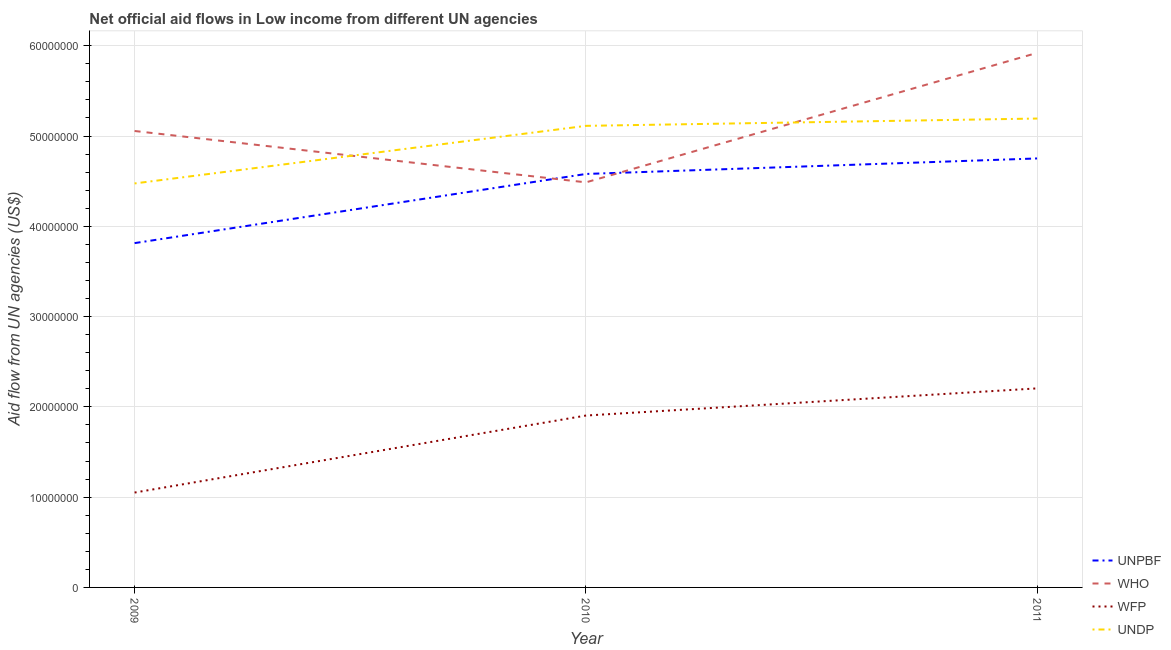How many different coloured lines are there?
Provide a succinct answer. 4. Is the number of lines equal to the number of legend labels?
Make the answer very short. Yes. What is the amount of aid given by who in 2011?
Make the answer very short. 5.92e+07. Across all years, what is the maximum amount of aid given by who?
Your answer should be compact. 5.92e+07. Across all years, what is the minimum amount of aid given by who?
Your answer should be compact. 4.49e+07. What is the total amount of aid given by undp in the graph?
Offer a very short reply. 1.48e+08. What is the difference between the amount of aid given by who in 2009 and that in 2010?
Offer a very short reply. 5.69e+06. What is the difference between the amount of aid given by unpbf in 2009 and the amount of aid given by who in 2010?
Your response must be concise. -6.73e+06. What is the average amount of aid given by who per year?
Provide a short and direct response. 5.16e+07. In the year 2009, what is the difference between the amount of aid given by wfp and amount of aid given by undp?
Provide a succinct answer. -3.42e+07. What is the ratio of the amount of aid given by unpbf in 2009 to that in 2011?
Offer a very short reply. 0.8. What is the difference between the highest and the second highest amount of aid given by who?
Your answer should be compact. 8.66e+06. What is the difference between the highest and the lowest amount of aid given by undp?
Your response must be concise. 7.19e+06. In how many years, is the amount of aid given by unpbf greater than the average amount of aid given by unpbf taken over all years?
Provide a short and direct response. 2. Is the sum of the amount of aid given by wfp in 2010 and 2011 greater than the maximum amount of aid given by who across all years?
Offer a terse response. No. Is it the case that in every year, the sum of the amount of aid given by unpbf and amount of aid given by undp is greater than the sum of amount of aid given by who and amount of aid given by wfp?
Give a very brief answer. No. Does the amount of aid given by undp monotonically increase over the years?
Offer a terse response. Yes. Does the graph contain grids?
Offer a very short reply. Yes. Where does the legend appear in the graph?
Your answer should be very brief. Bottom right. How many legend labels are there?
Your answer should be compact. 4. How are the legend labels stacked?
Give a very brief answer. Vertical. What is the title of the graph?
Give a very brief answer. Net official aid flows in Low income from different UN agencies. Does "Industry" appear as one of the legend labels in the graph?
Your answer should be compact. No. What is the label or title of the Y-axis?
Make the answer very short. Aid flow from UN agencies (US$). What is the Aid flow from UN agencies (US$) of UNPBF in 2009?
Keep it short and to the point. 3.81e+07. What is the Aid flow from UN agencies (US$) in WHO in 2009?
Offer a very short reply. 5.06e+07. What is the Aid flow from UN agencies (US$) of WFP in 2009?
Provide a short and direct response. 1.05e+07. What is the Aid flow from UN agencies (US$) of UNDP in 2009?
Make the answer very short. 4.48e+07. What is the Aid flow from UN agencies (US$) in UNPBF in 2010?
Your response must be concise. 4.58e+07. What is the Aid flow from UN agencies (US$) of WHO in 2010?
Offer a terse response. 4.49e+07. What is the Aid flow from UN agencies (US$) in WFP in 2010?
Your answer should be compact. 1.90e+07. What is the Aid flow from UN agencies (US$) of UNDP in 2010?
Offer a terse response. 5.11e+07. What is the Aid flow from UN agencies (US$) in UNPBF in 2011?
Make the answer very short. 4.75e+07. What is the Aid flow from UN agencies (US$) in WHO in 2011?
Your answer should be very brief. 5.92e+07. What is the Aid flow from UN agencies (US$) of WFP in 2011?
Provide a succinct answer. 2.20e+07. What is the Aid flow from UN agencies (US$) of UNDP in 2011?
Provide a short and direct response. 5.19e+07. Across all years, what is the maximum Aid flow from UN agencies (US$) in UNPBF?
Make the answer very short. 4.75e+07. Across all years, what is the maximum Aid flow from UN agencies (US$) of WHO?
Offer a very short reply. 5.92e+07. Across all years, what is the maximum Aid flow from UN agencies (US$) of WFP?
Keep it short and to the point. 2.20e+07. Across all years, what is the maximum Aid flow from UN agencies (US$) of UNDP?
Keep it short and to the point. 5.19e+07. Across all years, what is the minimum Aid flow from UN agencies (US$) in UNPBF?
Keep it short and to the point. 3.81e+07. Across all years, what is the minimum Aid flow from UN agencies (US$) of WHO?
Your answer should be compact. 4.49e+07. Across all years, what is the minimum Aid flow from UN agencies (US$) of WFP?
Your answer should be very brief. 1.05e+07. Across all years, what is the minimum Aid flow from UN agencies (US$) of UNDP?
Offer a terse response. 4.48e+07. What is the total Aid flow from UN agencies (US$) in UNPBF in the graph?
Your response must be concise. 1.31e+08. What is the total Aid flow from UN agencies (US$) of WHO in the graph?
Offer a very short reply. 1.55e+08. What is the total Aid flow from UN agencies (US$) of WFP in the graph?
Keep it short and to the point. 5.16e+07. What is the total Aid flow from UN agencies (US$) in UNDP in the graph?
Your response must be concise. 1.48e+08. What is the difference between the Aid flow from UN agencies (US$) of UNPBF in 2009 and that in 2010?
Provide a succinct answer. -7.66e+06. What is the difference between the Aid flow from UN agencies (US$) of WHO in 2009 and that in 2010?
Your answer should be very brief. 5.69e+06. What is the difference between the Aid flow from UN agencies (US$) of WFP in 2009 and that in 2010?
Keep it short and to the point. -8.53e+06. What is the difference between the Aid flow from UN agencies (US$) in UNDP in 2009 and that in 2010?
Your answer should be compact. -6.38e+06. What is the difference between the Aid flow from UN agencies (US$) of UNPBF in 2009 and that in 2011?
Your answer should be compact. -9.38e+06. What is the difference between the Aid flow from UN agencies (US$) in WHO in 2009 and that in 2011?
Ensure brevity in your answer.  -8.66e+06. What is the difference between the Aid flow from UN agencies (US$) of WFP in 2009 and that in 2011?
Ensure brevity in your answer.  -1.15e+07. What is the difference between the Aid flow from UN agencies (US$) of UNDP in 2009 and that in 2011?
Offer a very short reply. -7.19e+06. What is the difference between the Aid flow from UN agencies (US$) of UNPBF in 2010 and that in 2011?
Provide a succinct answer. -1.72e+06. What is the difference between the Aid flow from UN agencies (US$) of WHO in 2010 and that in 2011?
Provide a succinct answer. -1.44e+07. What is the difference between the Aid flow from UN agencies (US$) in WFP in 2010 and that in 2011?
Provide a succinct answer. -3.01e+06. What is the difference between the Aid flow from UN agencies (US$) of UNDP in 2010 and that in 2011?
Provide a short and direct response. -8.10e+05. What is the difference between the Aid flow from UN agencies (US$) in UNPBF in 2009 and the Aid flow from UN agencies (US$) in WHO in 2010?
Make the answer very short. -6.73e+06. What is the difference between the Aid flow from UN agencies (US$) of UNPBF in 2009 and the Aid flow from UN agencies (US$) of WFP in 2010?
Provide a short and direct response. 1.91e+07. What is the difference between the Aid flow from UN agencies (US$) in UNPBF in 2009 and the Aid flow from UN agencies (US$) in UNDP in 2010?
Offer a very short reply. -1.30e+07. What is the difference between the Aid flow from UN agencies (US$) of WHO in 2009 and the Aid flow from UN agencies (US$) of WFP in 2010?
Offer a very short reply. 3.15e+07. What is the difference between the Aid flow from UN agencies (US$) of WHO in 2009 and the Aid flow from UN agencies (US$) of UNDP in 2010?
Provide a succinct answer. -5.70e+05. What is the difference between the Aid flow from UN agencies (US$) in WFP in 2009 and the Aid flow from UN agencies (US$) in UNDP in 2010?
Provide a succinct answer. -4.06e+07. What is the difference between the Aid flow from UN agencies (US$) of UNPBF in 2009 and the Aid flow from UN agencies (US$) of WHO in 2011?
Give a very brief answer. -2.11e+07. What is the difference between the Aid flow from UN agencies (US$) of UNPBF in 2009 and the Aid flow from UN agencies (US$) of WFP in 2011?
Offer a very short reply. 1.61e+07. What is the difference between the Aid flow from UN agencies (US$) of UNPBF in 2009 and the Aid flow from UN agencies (US$) of UNDP in 2011?
Keep it short and to the point. -1.38e+07. What is the difference between the Aid flow from UN agencies (US$) in WHO in 2009 and the Aid flow from UN agencies (US$) in WFP in 2011?
Offer a terse response. 2.85e+07. What is the difference between the Aid flow from UN agencies (US$) in WHO in 2009 and the Aid flow from UN agencies (US$) in UNDP in 2011?
Provide a succinct answer. -1.38e+06. What is the difference between the Aid flow from UN agencies (US$) of WFP in 2009 and the Aid flow from UN agencies (US$) of UNDP in 2011?
Your answer should be compact. -4.14e+07. What is the difference between the Aid flow from UN agencies (US$) in UNPBF in 2010 and the Aid flow from UN agencies (US$) in WHO in 2011?
Offer a terse response. -1.34e+07. What is the difference between the Aid flow from UN agencies (US$) of UNPBF in 2010 and the Aid flow from UN agencies (US$) of WFP in 2011?
Ensure brevity in your answer.  2.38e+07. What is the difference between the Aid flow from UN agencies (US$) of UNPBF in 2010 and the Aid flow from UN agencies (US$) of UNDP in 2011?
Your answer should be compact. -6.14e+06. What is the difference between the Aid flow from UN agencies (US$) of WHO in 2010 and the Aid flow from UN agencies (US$) of WFP in 2011?
Offer a terse response. 2.28e+07. What is the difference between the Aid flow from UN agencies (US$) in WHO in 2010 and the Aid flow from UN agencies (US$) in UNDP in 2011?
Provide a succinct answer. -7.07e+06. What is the difference between the Aid flow from UN agencies (US$) in WFP in 2010 and the Aid flow from UN agencies (US$) in UNDP in 2011?
Offer a terse response. -3.29e+07. What is the average Aid flow from UN agencies (US$) of UNPBF per year?
Make the answer very short. 4.38e+07. What is the average Aid flow from UN agencies (US$) in WHO per year?
Provide a succinct answer. 5.16e+07. What is the average Aid flow from UN agencies (US$) of WFP per year?
Provide a succinct answer. 1.72e+07. What is the average Aid flow from UN agencies (US$) of UNDP per year?
Offer a very short reply. 4.93e+07. In the year 2009, what is the difference between the Aid flow from UN agencies (US$) in UNPBF and Aid flow from UN agencies (US$) in WHO?
Keep it short and to the point. -1.24e+07. In the year 2009, what is the difference between the Aid flow from UN agencies (US$) in UNPBF and Aid flow from UN agencies (US$) in WFP?
Keep it short and to the point. 2.76e+07. In the year 2009, what is the difference between the Aid flow from UN agencies (US$) of UNPBF and Aid flow from UN agencies (US$) of UNDP?
Offer a terse response. -6.61e+06. In the year 2009, what is the difference between the Aid flow from UN agencies (US$) in WHO and Aid flow from UN agencies (US$) in WFP?
Keep it short and to the point. 4.00e+07. In the year 2009, what is the difference between the Aid flow from UN agencies (US$) in WHO and Aid flow from UN agencies (US$) in UNDP?
Provide a short and direct response. 5.81e+06. In the year 2009, what is the difference between the Aid flow from UN agencies (US$) in WFP and Aid flow from UN agencies (US$) in UNDP?
Keep it short and to the point. -3.42e+07. In the year 2010, what is the difference between the Aid flow from UN agencies (US$) in UNPBF and Aid flow from UN agencies (US$) in WHO?
Keep it short and to the point. 9.30e+05. In the year 2010, what is the difference between the Aid flow from UN agencies (US$) in UNPBF and Aid flow from UN agencies (US$) in WFP?
Your response must be concise. 2.68e+07. In the year 2010, what is the difference between the Aid flow from UN agencies (US$) of UNPBF and Aid flow from UN agencies (US$) of UNDP?
Provide a short and direct response. -5.33e+06. In the year 2010, what is the difference between the Aid flow from UN agencies (US$) in WHO and Aid flow from UN agencies (US$) in WFP?
Your response must be concise. 2.58e+07. In the year 2010, what is the difference between the Aid flow from UN agencies (US$) of WHO and Aid flow from UN agencies (US$) of UNDP?
Provide a short and direct response. -6.26e+06. In the year 2010, what is the difference between the Aid flow from UN agencies (US$) in WFP and Aid flow from UN agencies (US$) in UNDP?
Your response must be concise. -3.21e+07. In the year 2011, what is the difference between the Aid flow from UN agencies (US$) in UNPBF and Aid flow from UN agencies (US$) in WHO?
Provide a short and direct response. -1.17e+07. In the year 2011, what is the difference between the Aid flow from UN agencies (US$) of UNPBF and Aid flow from UN agencies (US$) of WFP?
Your answer should be very brief. 2.55e+07. In the year 2011, what is the difference between the Aid flow from UN agencies (US$) in UNPBF and Aid flow from UN agencies (US$) in UNDP?
Your answer should be very brief. -4.42e+06. In the year 2011, what is the difference between the Aid flow from UN agencies (US$) of WHO and Aid flow from UN agencies (US$) of WFP?
Your answer should be compact. 3.72e+07. In the year 2011, what is the difference between the Aid flow from UN agencies (US$) of WHO and Aid flow from UN agencies (US$) of UNDP?
Provide a succinct answer. 7.28e+06. In the year 2011, what is the difference between the Aid flow from UN agencies (US$) in WFP and Aid flow from UN agencies (US$) in UNDP?
Offer a terse response. -2.99e+07. What is the ratio of the Aid flow from UN agencies (US$) in UNPBF in 2009 to that in 2010?
Your response must be concise. 0.83. What is the ratio of the Aid flow from UN agencies (US$) of WHO in 2009 to that in 2010?
Keep it short and to the point. 1.13. What is the ratio of the Aid flow from UN agencies (US$) in WFP in 2009 to that in 2010?
Offer a very short reply. 0.55. What is the ratio of the Aid flow from UN agencies (US$) of UNDP in 2009 to that in 2010?
Offer a terse response. 0.88. What is the ratio of the Aid flow from UN agencies (US$) in UNPBF in 2009 to that in 2011?
Provide a short and direct response. 0.8. What is the ratio of the Aid flow from UN agencies (US$) of WHO in 2009 to that in 2011?
Give a very brief answer. 0.85. What is the ratio of the Aid flow from UN agencies (US$) in WFP in 2009 to that in 2011?
Your answer should be compact. 0.48. What is the ratio of the Aid flow from UN agencies (US$) of UNDP in 2009 to that in 2011?
Provide a succinct answer. 0.86. What is the ratio of the Aid flow from UN agencies (US$) in UNPBF in 2010 to that in 2011?
Make the answer very short. 0.96. What is the ratio of the Aid flow from UN agencies (US$) of WHO in 2010 to that in 2011?
Provide a succinct answer. 0.76. What is the ratio of the Aid flow from UN agencies (US$) of WFP in 2010 to that in 2011?
Your response must be concise. 0.86. What is the ratio of the Aid flow from UN agencies (US$) of UNDP in 2010 to that in 2011?
Offer a terse response. 0.98. What is the difference between the highest and the second highest Aid flow from UN agencies (US$) in UNPBF?
Your response must be concise. 1.72e+06. What is the difference between the highest and the second highest Aid flow from UN agencies (US$) in WHO?
Your answer should be compact. 8.66e+06. What is the difference between the highest and the second highest Aid flow from UN agencies (US$) in WFP?
Make the answer very short. 3.01e+06. What is the difference between the highest and the second highest Aid flow from UN agencies (US$) in UNDP?
Provide a succinct answer. 8.10e+05. What is the difference between the highest and the lowest Aid flow from UN agencies (US$) of UNPBF?
Your answer should be very brief. 9.38e+06. What is the difference between the highest and the lowest Aid flow from UN agencies (US$) of WHO?
Give a very brief answer. 1.44e+07. What is the difference between the highest and the lowest Aid flow from UN agencies (US$) in WFP?
Keep it short and to the point. 1.15e+07. What is the difference between the highest and the lowest Aid flow from UN agencies (US$) of UNDP?
Ensure brevity in your answer.  7.19e+06. 